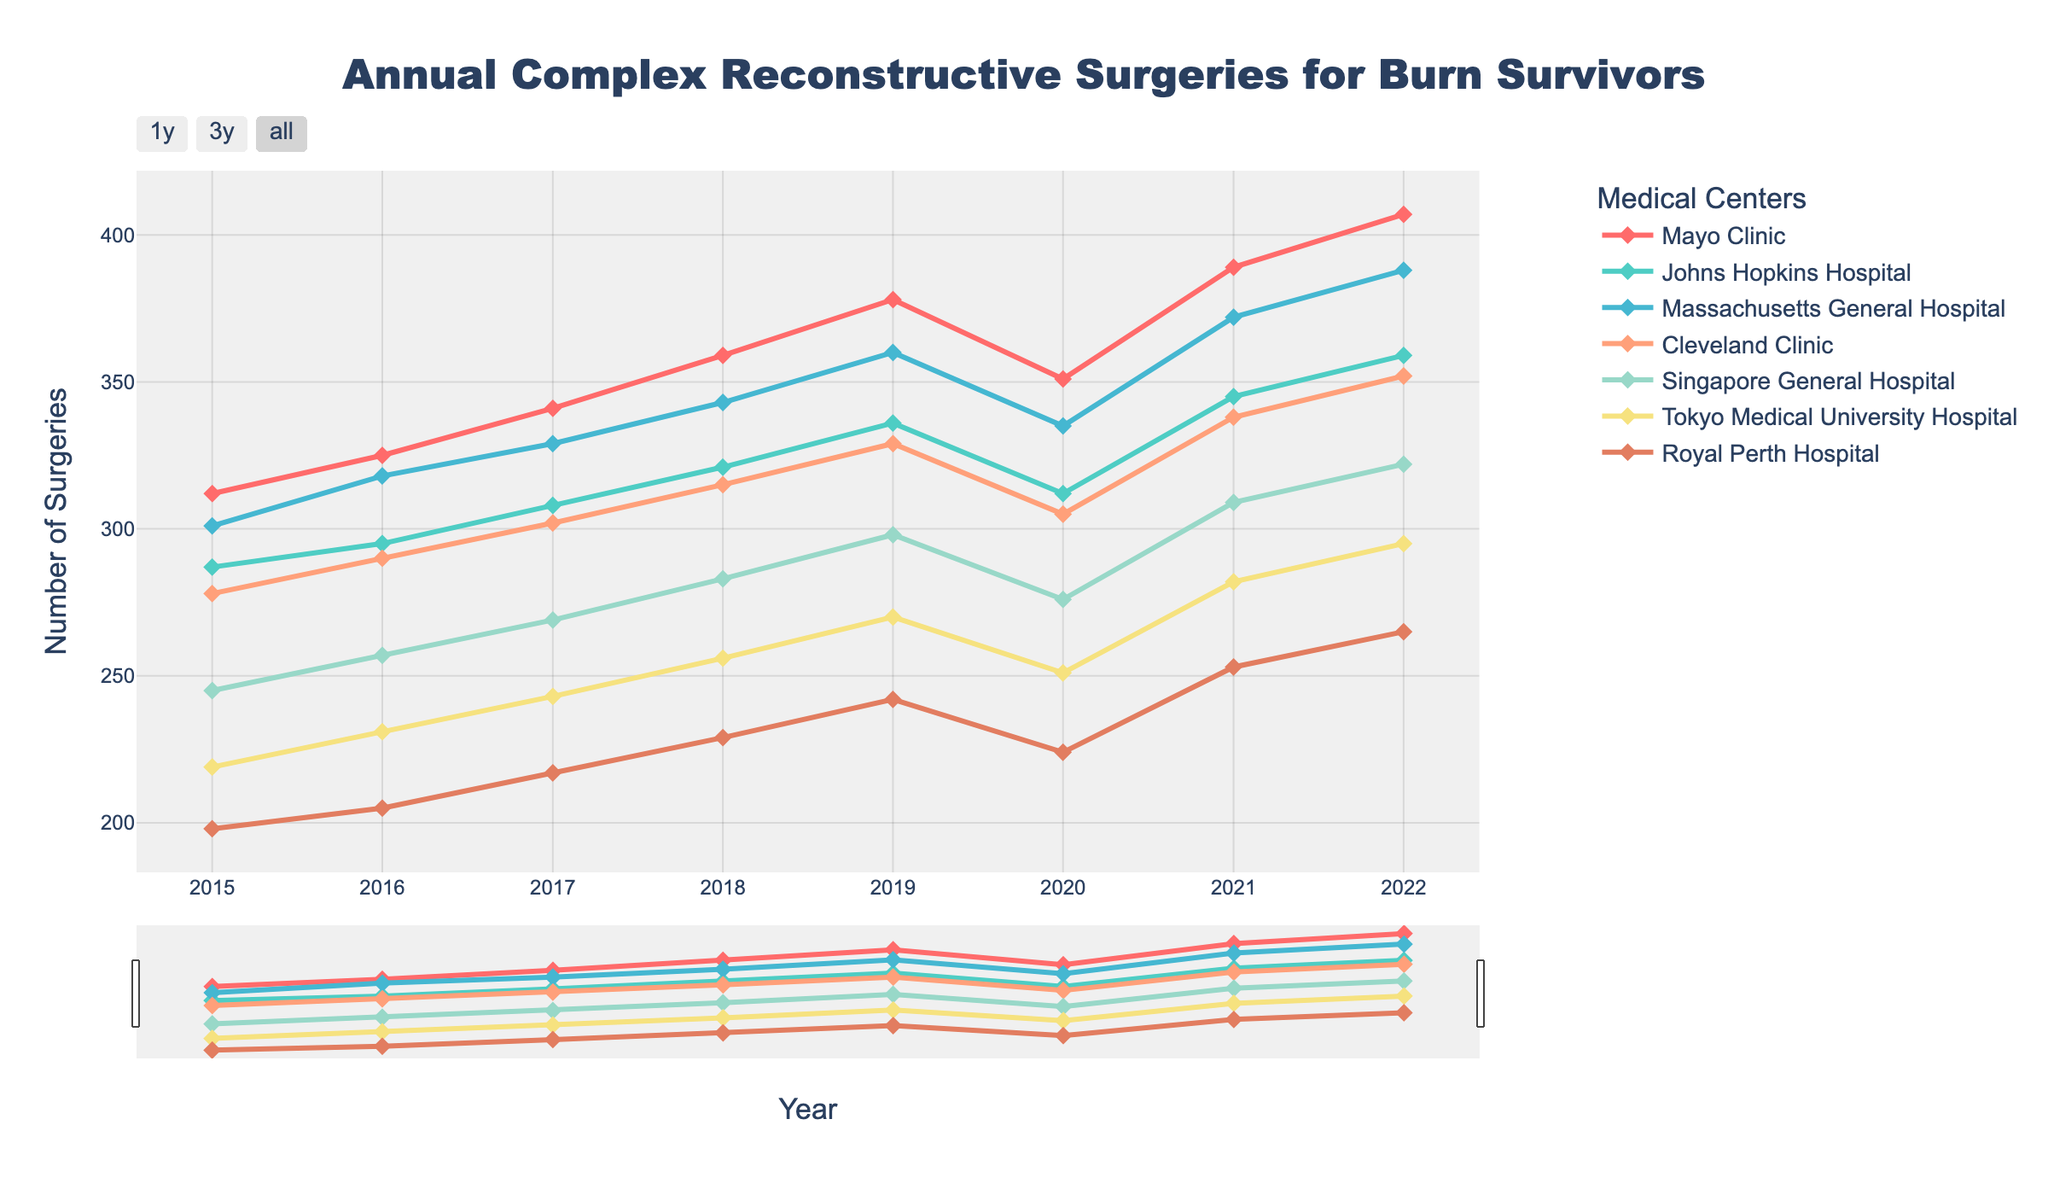What was the trend of surgeries at Mayo Clinic from 2015 to 2022? To determine the trend, we look at the number of surgeries each year at Mayo Clinic. The numbers start from 312 in 2015 and generally increase each year, with a dip in 2020, then continuing to increase, reaching 407 in 2022. Hence the trend is generally upward with a slight decrease in 2020.
Answer: Upward trend with a dip in 2020 Which hospital had the highest number of surgeries in 2022? In 2022, Mayo Clinic had 407, Johns Hopkins Hospital had 359, Massachusetts General Hospital had 388, Cleveland Clinic had 352, Singapore General Hospital had 322, Tokyo Medical University Hospital had 295, and Royal Perth Hospital had 265 surgeries. Mayo Clinic had the highest number of surgeries at 407.
Answer: Mayo Clinic How did the number of surgeries at Cleveland Clinic change from 2016 to 2018? In 2016, Cleveland Clinic performed 290 surgeries, in 2017 302 surgeries, and in 2018 315 surgeries. The number of surgeries increased each year during this period.
Answer: Increased What was the combined total of surgeries performed at Johns Hopkins Hospital and Singapore General Hospital in 2020? In 2020, Johns Hopkins Hospital performed 312 surgeries, and Singapore General Hospital performed 276 surgeries. Summing these up gives 312 + 276 = 588 surgeries.
Answer: 588 From 2015 to 2022, which hospital showed the most significant increase in the number of surgeries performed? For each hospital, we calculate the change in surgeries from 2015 to 2022: Mayo Clinic: 407 - 312 = 95, Johns Hopkins Hospital: 359 - 287 = 72, Massachusetts General Hospital: 388 - 301 = 87, Cleveland Clinic: 352 - 278 = 74, Singapore General Hospital: 322 - 245 = 77, Tokyo Medical University Hospital: 295 - 219 = 76, Royal Perth Hospital: 265 - 198 = 67. Mayo Clinic showed the most significant increase of 95.
Answer: Mayo Clinic Which hospitals had a dip in surgeries in 2020, compared to 2019? Comparing the number of surgeries in 2019 and 2020: Mayo Clinic: 378 in 2019 to 351 in 2020, Johns Hopkins Hospital: 336 to 312, Massachusetts General Hospital: 360 to 335, Cleveland Clinic: 329 to 305, Singapore General Hospital: 298 to 276, Tokyo Medical University Hospital: 270 to 251, Royal Perth Hospital: 242 to 224. All hospitals had a dip in surgeries in 2020.
Answer: All hospitals What was the average number of surgeries performed at Tokyo Medical University Hospital from 2015 to 2022? The number of surgeries for Tokyo Medical University Hospital are: 219 in 2015, 231 in 2016, 243 in 2017, 256 in 2018, 270 in 2019, 251 in 2020, 282 in 2021, and 295 in 2022. Summing these and dividing by 8, we get (219 + 231 + 243 + 256 + 270 + 251 + 282 + 295) / 8 = 2047 / 8 = 255.875.
Answer: 255.875 In which year did Massachusetts General Hospital surpass 350 surgeries for the first time? Looking at the data, Massachusetts General Hospital performed 360 surgeries in 2019, which is the first time it surpassed 350 surgeries.
Answer: 2019 How did the numbers at Royal Perth Hospital compare between 2016 and 2022? In 2016, Royal Perth Hospital performed 205 surgeries and in 2022, it performed 265 surgeries. Thus, the number increased from 205 to 265.
Answer: Increased Which hospital consistently had the lowest number of surgeries from 2015 to 2022? Checking each year's data for all hospitals, Royal Perth Hospital always had the lowest number of surgeries compared to the others.
Answer: Royal Perth Hospital 